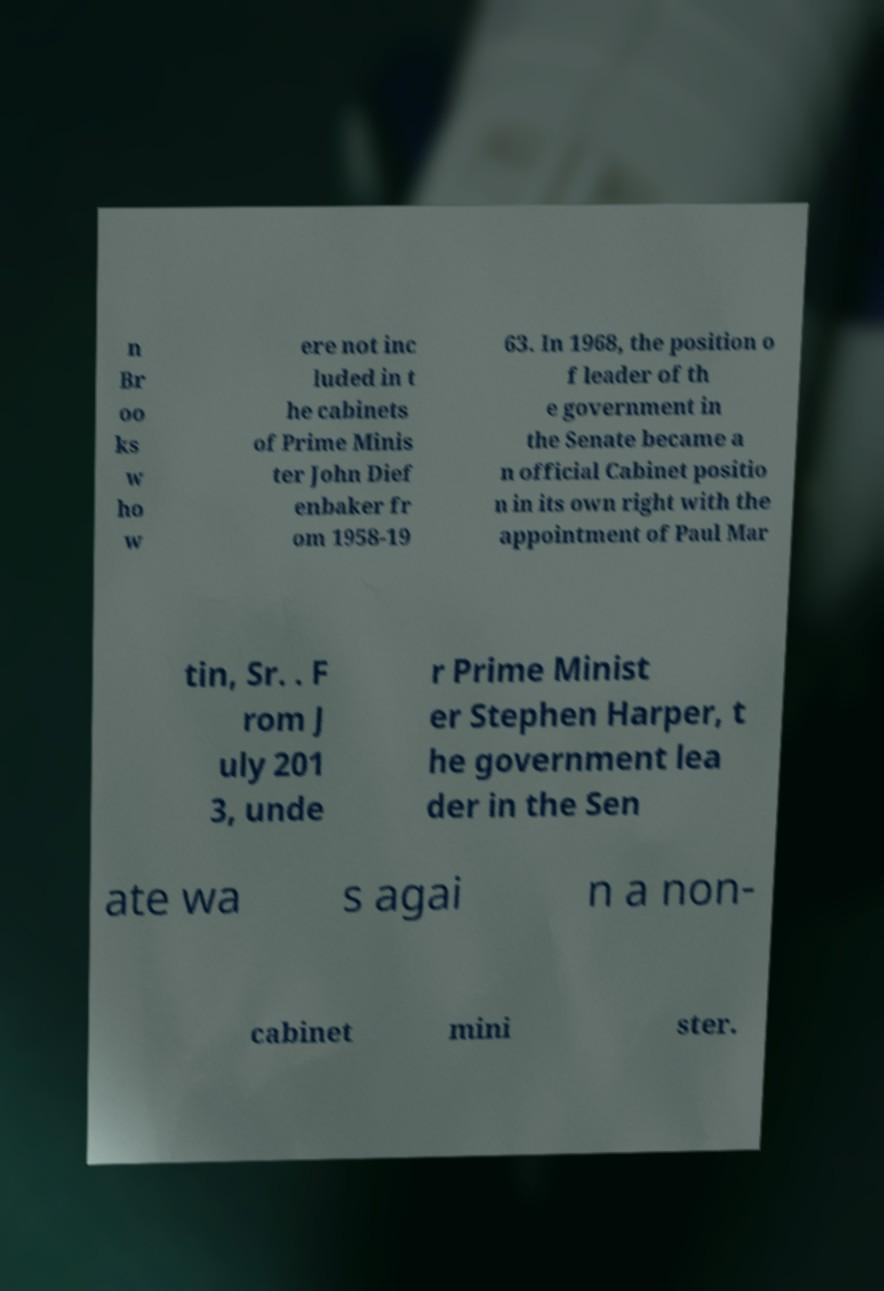Please read and relay the text visible in this image. What does it say? n Br oo ks w ho w ere not inc luded in t he cabinets of Prime Minis ter John Dief enbaker fr om 1958-19 63. In 1968, the position o f leader of th e government in the Senate became a n official Cabinet positio n in its own right with the appointment of Paul Mar tin, Sr. . F rom J uly 201 3, unde r Prime Minist er Stephen Harper, t he government lea der in the Sen ate wa s agai n a non- cabinet mini ster. 